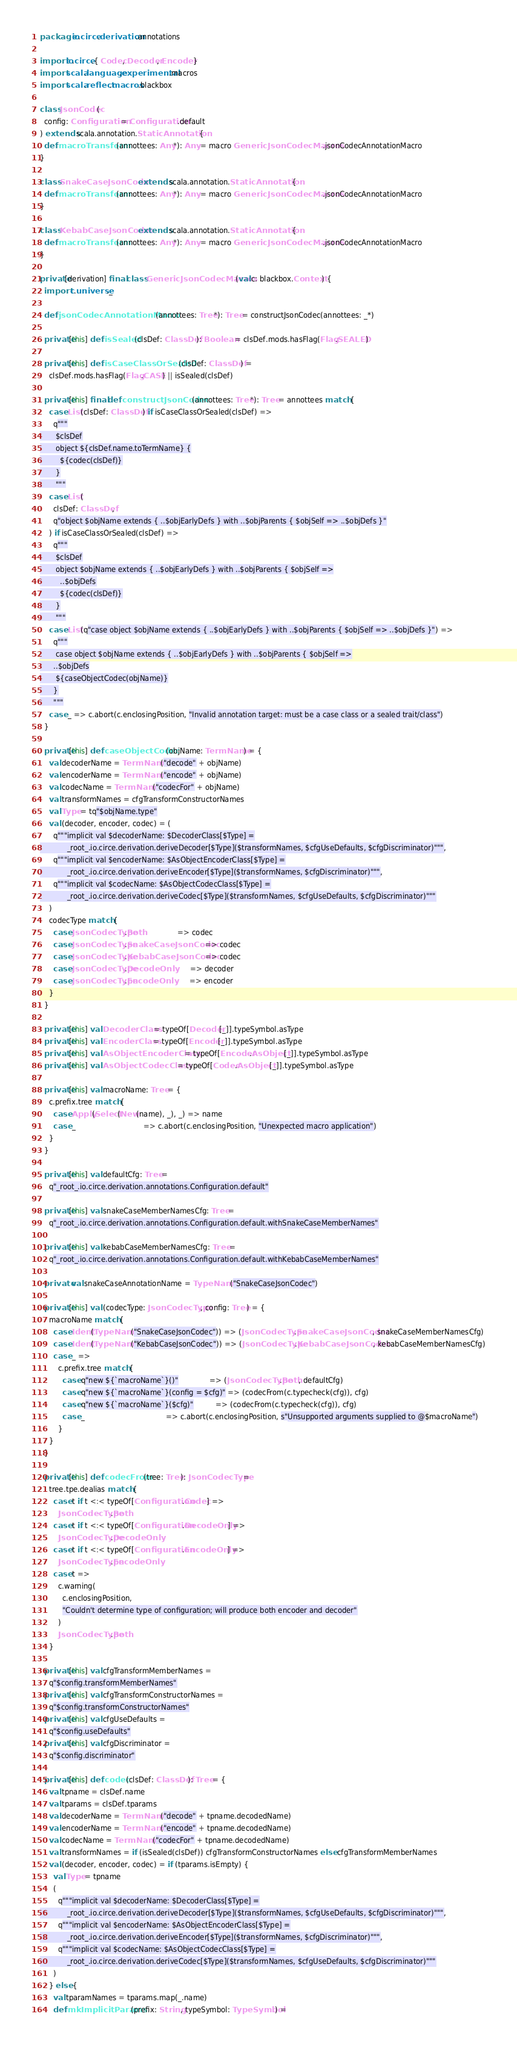Convert code to text. <code><loc_0><loc_0><loc_500><loc_500><_Scala_>package io.circe.derivation.annotations

import io.circe.{ Codec, Decoder, Encoder }
import scala.language.experimental.macros
import scala.reflect.macros.blackbox

class JsonCodec(
  config: Configuration = Configuration.default
) extends scala.annotation.StaticAnnotation {
  def macroTransform(annottees: Any*): Any = macro GenericJsonCodecMacros.jsonCodecAnnotationMacro
}

class SnakeCaseJsonCodec extends scala.annotation.StaticAnnotation {
  def macroTransform(annottees: Any*): Any = macro GenericJsonCodecMacros.jsonCodecAnnotationMacro
}

class KebabCaseJsonCodec extends scala.annotation.StaticAnnotation {
  def macroTransform(annottees: Any*): Any = macro GenericJsonCodecMacros.jsonCodecAnnotationMacro
}

private[derivation] final class GenericJsonCodecMacros(val c: blackbox.Context) {
  import c.universe._

  def jsonCodecAnnotationMacro(annottees: Tree*): Tree = constructJsonCodec(annottees: _*)

  private[this] def isSealed(clsDef: ClassDef): Boolean = clsDef.mods.hasFlag(Flag.SEALED)

  private[this] def isCaseClassOrSealed(clsDef: ClassDef) =
    clsDef.mods.hasFlag(Flag.CASE) || isSealed(clsDef)

  private[this] final def constructJsonCodec(annottees: Tree*): Tree = annottees match {
    case List(clsDef: ClassDef) if isCaseClassOrSealed(clsDef) =>
      q"""
       $clsDef
       object ${clsDef.name.toTermName} {
         ${codec(clsDef)}
       }
       """
    case List(
      clsDef: ClassDef,
      q"object $objName extends { ..$objEarlyDefs } with ..$objParents { $objSelf => ..$objDefs }"
    ) if isCaseClassOrSealed(clsDef) =>
      q"""
       $clsDef
       object $objName extends { ..$objEarlyDefs } with ..$objParents { $objSelf =>
         ..$objDefs
         ${codec(clsDef)}
       }
       """
    case List(q"case object $objName extends { ..$objEarlyDefs } with ..$objParents { $objSelf => ..$objDefs }") =>
      q"""
       case object $objName extends { ..$objEarlyDefs } with ..$objParents { $objSelf =>
      ..$objDefs
       ${caseObjectCodec(objName)}
      }
      """
    case _ => c.abort(c.enclosingPosition, "Invalid annotation target: must be a case class or a sealed trait/class")
  }

  private[this] def caseObjectCodec(objName: TermName) = {
    val decoderName = TermName("decode" + objName)
    val encoderName = TermName("encode" + objName)
    val codecName = TermName("codecFor" + objName)
    val transformNames = cfgTransformConstructorNames
    val Type = tq"$objName.type"
    val (decoder, encoder, codec) = (
      q"""implicit val $decoderName: $DecoderClass[$Type] =
            _root_.io.circe.derivation.deriveDecoder[$Type]($transformNames, $cfgUseDefaults, $cfgDiscriminator)""",
      q"""implicit val $encoderName: $AsObjectEncoderClass[$Type] =
            _root_.io.circe.derivation.deriveEncoder[$Type]($transformNames, $cfgDiscriminator)""",
      q"""implicit val $codecName: $AsObjectCodecClass[$Type] =
            _root_.io.circe.derivation.deriveCodec[$Type]($transformNames, $cfgUseDefaults, $cfgDiscriminator)"""
    )
    codecType match {
      case JsonCodecType.Both               => codec
      case JsonCodecType.SnakeCaseJsonCodec => codec
      case JsonCodecType.KebabCaseJsonCodec => codec
      case JsonCodecType.DecodeOnly         => decoder
      case JsonCodecType.EncodeOnly         => encoder
    }
  }

  private[this] val DecoderClass = typeOf[Decoder[_]].typeSymbol.asType
  private[this] val EncoderClass = typeOf[Encoder[_]].typeSymbol.asType
  private[this] val AsObjectEncoderClass = typeOf[Encoder.AsObject[_]].typeSymbol.asType
  private[this] val AsObjectCodecClass = typeOf[Codec.AsObject[_]].typeSymbol.asType

  private[this] val macroName: Tree = {
    c.prefix.tree match {
      case Apply(Select(New(name), _), _) => name
      case _                              => c.abort(c.enclosingPosition, "Unexpected macro application")
    }
  }

  private[this] val defaultCfg: Tree =
    q"_root_.io.circe.derivation.annotations.Configuration.default"

  private[this] val snakeCaseMemberNamesCfg: Tree =
    q"_root_.io.circe.derivation.annotations.Configuration.default.withSnakeCaseMemberNames"

  private[this] val kebabCaseMemberNamesCfg: Tree =
    q"_root_.io.circe.derivation.annotations.Configuration.default.withKebabCaseMemberNames"

  private val snakeCaseAnnotationName = TypeName("SnakeCaseJsonCodec")

  private[this] val (codecType: JsonCodecType, config: Tree) = {
    macroName match {
      case Ident(TypeName("SnakeCaseJsonCodec")) => (JsonCodecType.SnakeCaseJsonCodec, snakeCaseMemberNamesCfg)
      case Ident(TypeName("KebabCaseJsonCodec")) => (JsonCodecType.KebabCaseJsonCodec, kebabCaseMemberNamesCfg)
      case _ =>
        c.prefix.tree match {
          case q"new ${`macroName`}()"              => (JsonCodecType.Both, defaultCfg)
          case q"new ${`macroName`}(config = $cfg)" => (codecFrom(c.typecheck(cfg)), cfg)
          case q"new ${`macroName`}($cfg)"          => (codecFrom(c.typecheck(cfg)), cfg)
          case _                                    => c.abort(c.enclosingPosition, s"Unsupported arguments supplied to @$macroName")
        }
    }
  }

  private[this] def codecFrom(tree: Tree): JsonCodecType =
    tree.tpe.dealias match {
      case t if t <:< typeOf[Configuration.Codec] =>
        JsonCodecType.Both
      case t if t <:< typeOf[Configuration.DecodeOnly] =>
        JsonCodecType.DecodeOnly
      case t if t <:< typeOf[Configuration.EncodeOnly] =>
        JsonCodecType.EncodeOnly
      case t =>
        c.warning(
          c.enclosingPosition,
          "Couldn't determine type of configuration; will produce both encoder and decoder"
        )
        JsonCodecType.Both
    }

  private[this] val cfgTransformMemberNames =
    q"$config.transformMemberNames"
  private[this] val cfgTransformConstructorNames =
    q"$config.transformConstructorNames"
  private[this] val cfgUseDefaults =
    q"$config.useDefaults"
  private[this] val cfgDiscriminator =
    q"$config.discriminator"

  private[this] def codec(clsDef: ClassDef): Tree = {
    val tpname = clsDef.name
    val tparams = clsDef.tparams
    val decoderName = TermName("decode" + tpname.decodedName)
    val encoderName = TermName("encode" + tpname.decodedName)
    val codecName = TermName("codecFor" + tpname.decodedName)
    val transformNames = if (isSealed(clsDef)) cfgTransformConstructorNames else cfgTransformMemberNames
    val (decoder, encoder, codec) = if (tparams.isEmpty) {
      val Type = tpname
      (
        q"""implicit val $decoderName: $DecoderClass[$Type] =
            _root_.io.circe.derivation.deriveDecoder[$Type]($transformNames, $cfgUseDefaults, $cfgDiscriminator)""",
        q"""implicit val $encoderName: $AsObjectEncoderClass[$Type] =
            _root_.io.circe.derivation.deriveEncoder[$Type]($transformNames, $cfgDiscriminator)""",
        q"""implicit val $codecName: $AsObjectCodecClass[$Type] =
            _root_.io.circe.derivation.deriveCodec[$Type]($transformNames, $cfgUseDefaults, $cfgDiscriminator)"""
      )
    } else {
      val tparamNames = tparams.map(_.name)
      def mkImplicitParams(prefix: String, typeSymbol: TypeSymbol) =</code> 